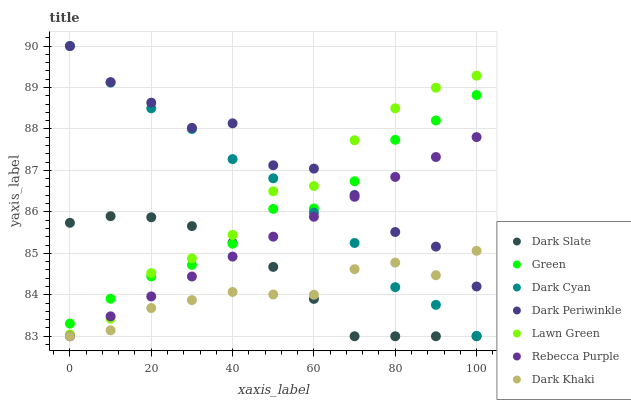Does Dark Khaki have the minimum area under the curve?
Answer yes or no. Yes. Does Dark Periwinkle have the maximum area under the curve?
Answer yes or no. Yes. Does Dark Slate have the minimum area under the curve?
Answer yes or no. No. Does Dark Slate have the maximum area under the curve?
Answer yes or no. No. Is Rebecca Purple the smoothest?
Answer yes or no. Yes. Is Dark Periwinkle the roughest?
Answer yes or no. Yes. Is Dark Khaki the smoothest?
Answer yes or no. No. Is Dark Khaki the roughest?
Answer yes or no. No. Does Dark Khaki have the lowest value?
Answer yes or no. Yes. Does Green have the lowest value?
Answer yes or no. No. Does Dark Periwinkle have the highest value?
Answer yes or no. Yes. Does Dark Slate have the highest value?
Answer yes or no. No. Is Dark Slate less than Dark Cyan?
Answer yes or no. Yes. Is Dark Cyan greater than Dark Slate?
Answer yes or no. Yes. Does Dark Khaki intersect Dark Periwinkle?
Answer yes or no. Yes. Is Dark Khaki less than Dark Periwinkle?
Answer yes or no. No. Is Dark Khaki greater than Dark Periwinkle?
Answer yes or no. No. Does Dark Slate intersect Dark Cyan?
Answer yes or no. No. 